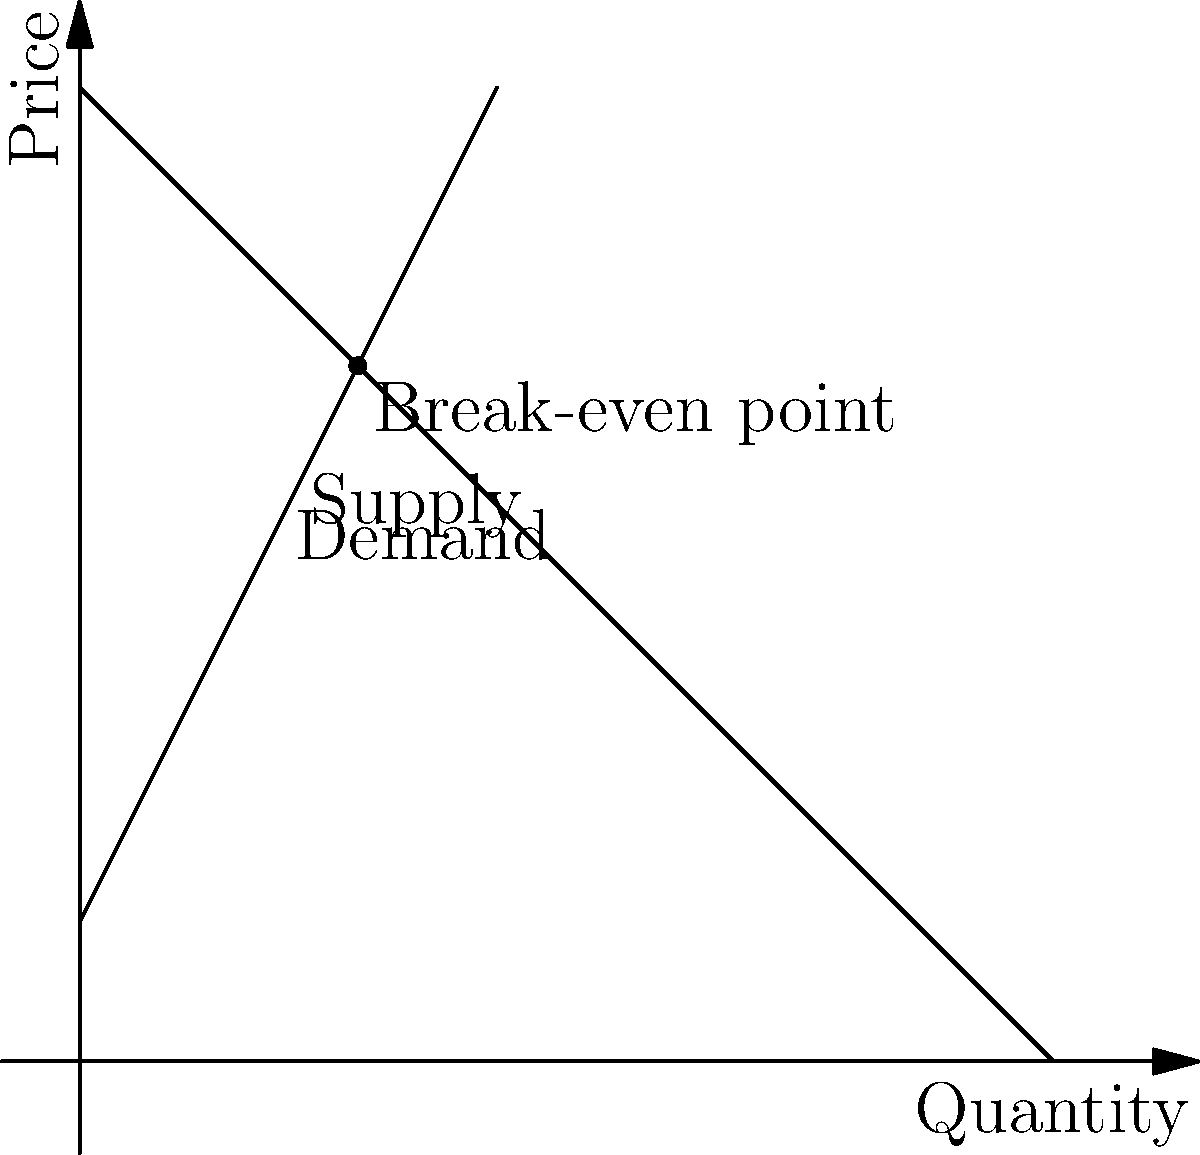As a social entrepreneur, you're developing a product with both profit and social impact in mind. Given the supply and demand curves shown in the graph, where the supply function is $P = 2Q + 10$ and the demand function is $P = -Q + 70$, calculate the break-even point (quantity and price) for your product. To find the break-even point, we need to solve the system of equations where supply equals demand:

1) Supply function: $P = 2Q + 10$
2) Demand function: $P = -Q + 70$

At the break-even point, these equations are equal:

3) $2Q + 10 = -Q + 70$

Now, let's solve for Q:

4) $3Q = 60$
5) $Q = 20$

To find the price at this quantity, we can substitute Q = 20 into either the supply or demand function. Let's use the supply function:

6) $P = 2(20) + 10 = 40 + 10 = 50$

Therefore, the break-even point occurs at a quantity of 20 units and a price of $50.
Answer: (20, $50) 